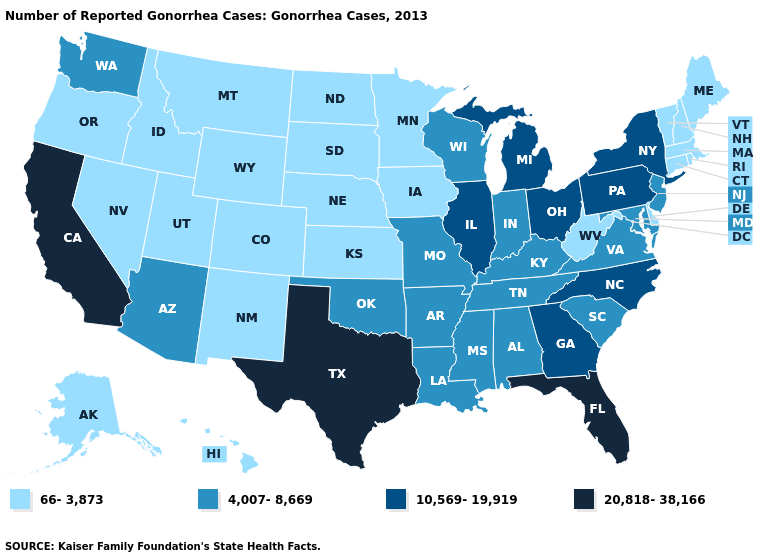Which states have the lowest value in the USA?
Be succinct. Alaska, Colorado, Connecticut, Delaware, Hawaii, Idaho, Iowa, Kansas, Maine, Massachusetts, Minnesota, Montana, Nebraska, Nevada, New Hampshire, New Mexico, North Dakota, Oregon, Rhode Island, South Dakota, Utah, Vermont, West Virginia, Wyoming. Among the states that border Missouri , which have the lowest value?
Answer briefly. Iowa, Kansas, Nebraska. Among the states that border Ohio , which have the highest value?
Be succinct. Michigan, Pennsylvania. Does the map have missing data?
Give a very brief answer. No. Which states have the lowest value in the USA?
Short answer required. Alaska, Colorado, Connecticut, Delaware, Hawaii, Idaho, Iowa, Kansas, Maine, Massachusetts, Minnesota, Montana, Nebraska, Nevada, New Hampshire, New Mexico, North Dakota, Oregon, Rhode Island, South Dakota, Utah, Vermont, West Virginia, Wyoming. Is the legend a continuous bar?
Write a very short answer. No. What is the value of Maryland?
Write a very short answer. 4,007-8,669. What is the value of New Jersey?
Keep it brief. 4,007-8,669. Name the states that have a value in the range 4,007-8,669?
Write a very short answer. Alabama, Arizona, Arkansas, Indiana, Kentucky, Louisiana, Maryland, Mississippi, Missouri, New Jersey, Oklahoma, South Carolina, Tennessee, Virginia, Washington, Wisconsin. Is the legend a continuous bar?
Concise answer only. No. Name the states that have a value in the range 20,818-38,166?
Keep it brief. California, Florida, Texas. What is the highest value in the USA?
Give a very brief answer. 20,818-38,166. What is the value of Massachusetts?
Concise answer only. 66-3,873. 